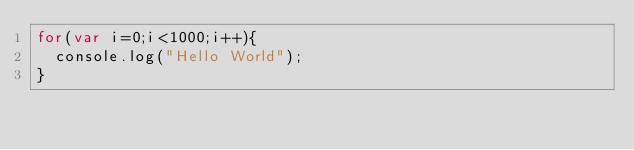<code> <loc_0><loc_0><loc_500><loc_500><_JavaScript_>for(var i=0;i<1000;i++){
  console.log("Hello World");
}
  </code> 